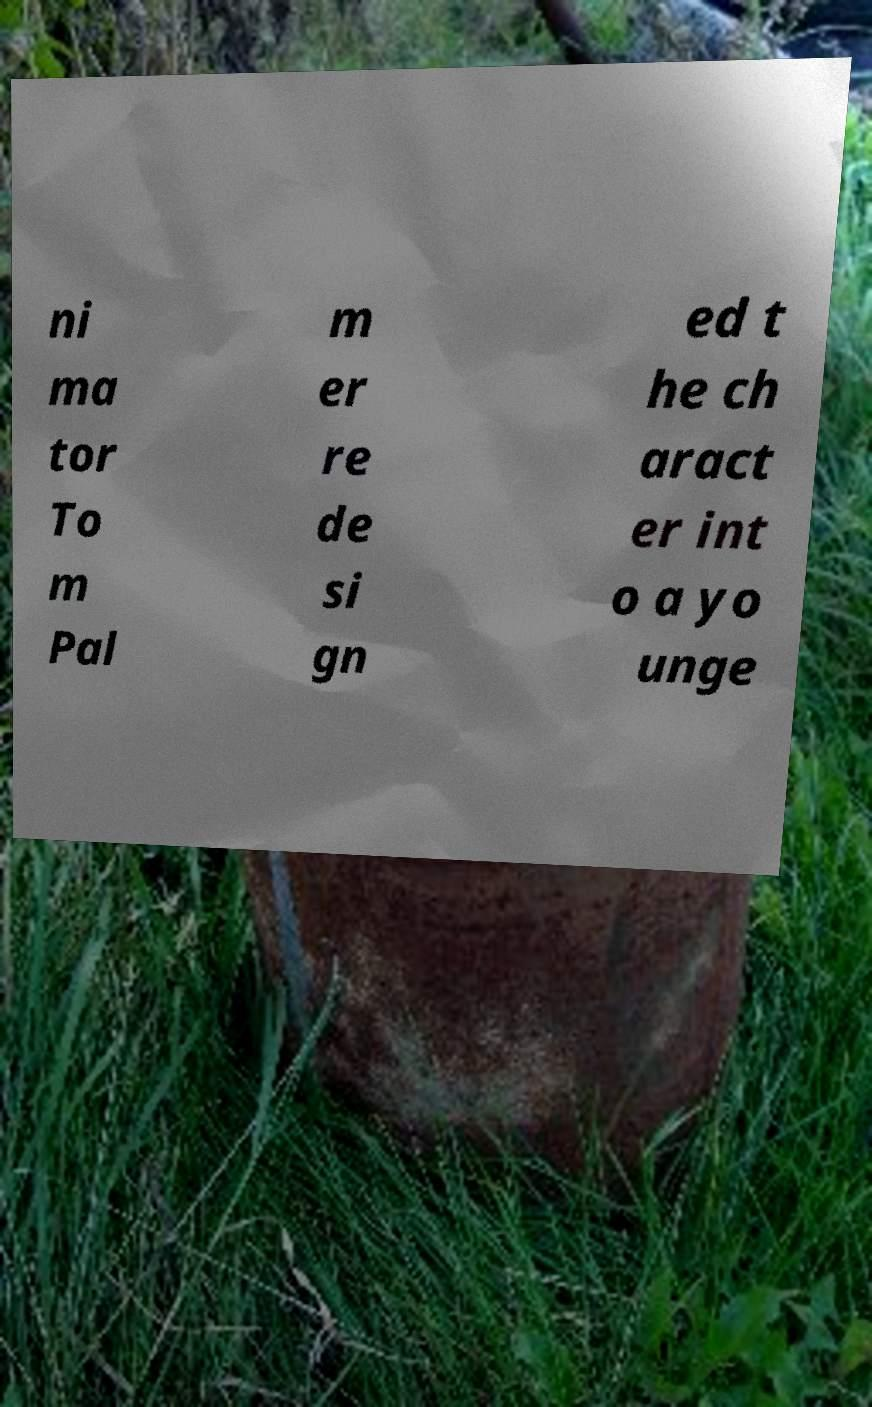For documentation purposes, I need the text within this image transcribed. Could you provide that? ni ma tor To m Pal m er re de si gn ed t he ch aract er int o a yo unge 